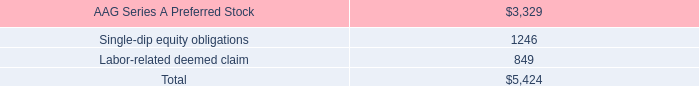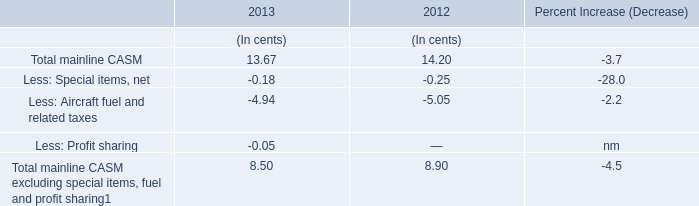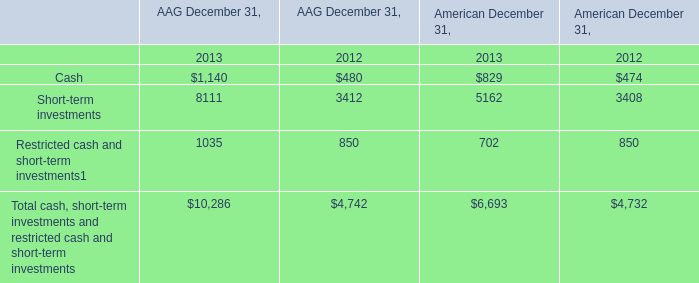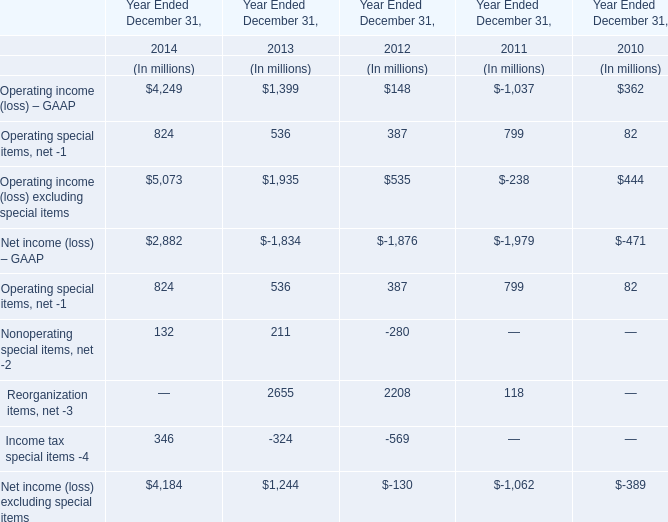What's the increasing rate of Operating special items, net in 2014? (in %) 
Computations: ((824 - 536) / 536)
Answer: 0.53731. 